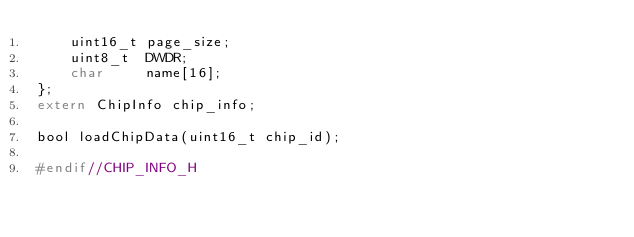<code> <loc_0><loc_0><loc_500><loc_500><_C_>    uint16_t page_size;
    uint8_t  DWDR;
    char     name[16];
};
extern ChipInfo chip_info;

bool loadChipData(uint16_t chip_id);

#endif//CHIP_INFO_H
</code> 